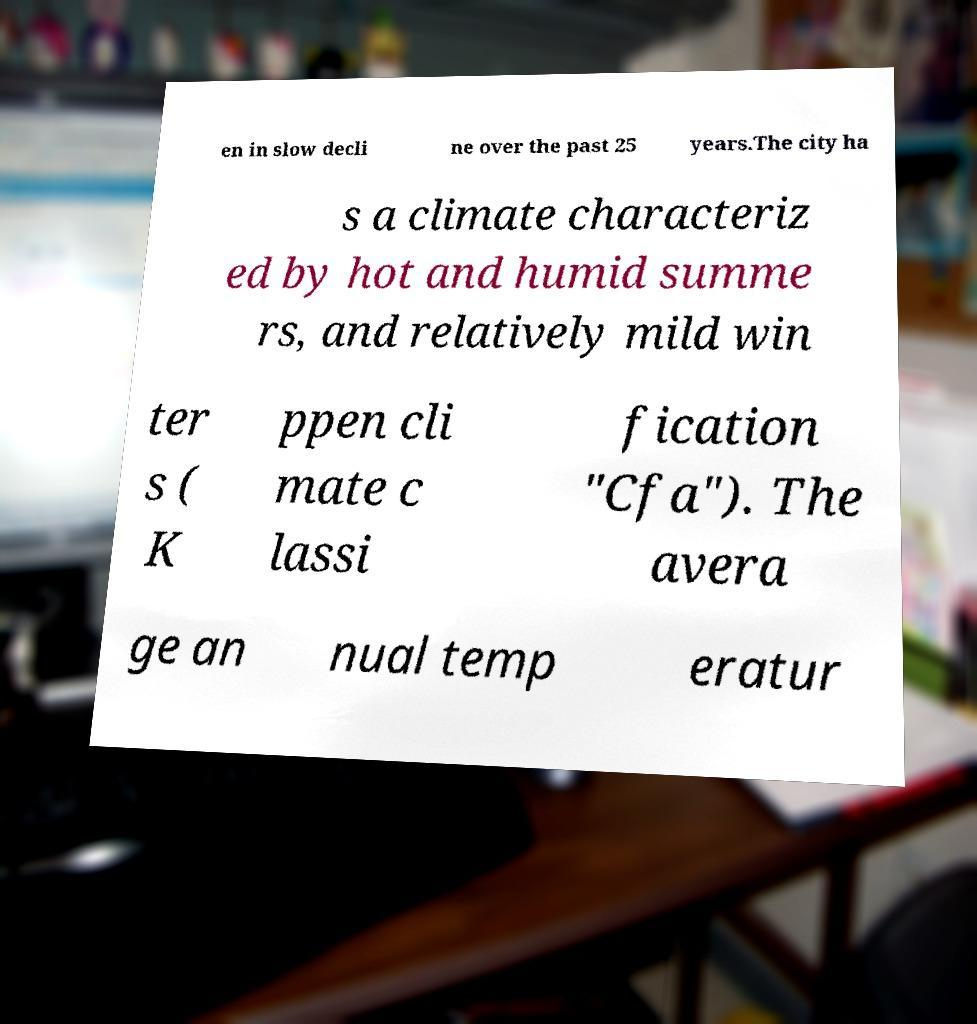I need the written content from this picture converted into text. Can you do that? en in slow decli ne over the past 25 years.The city ha s a climate characteriz ed by hot and humid summe rs, and relatively mild win ter s ( K ppen cli mate c lassi fication "Cfa"). The avera ge an nual temp eratur 